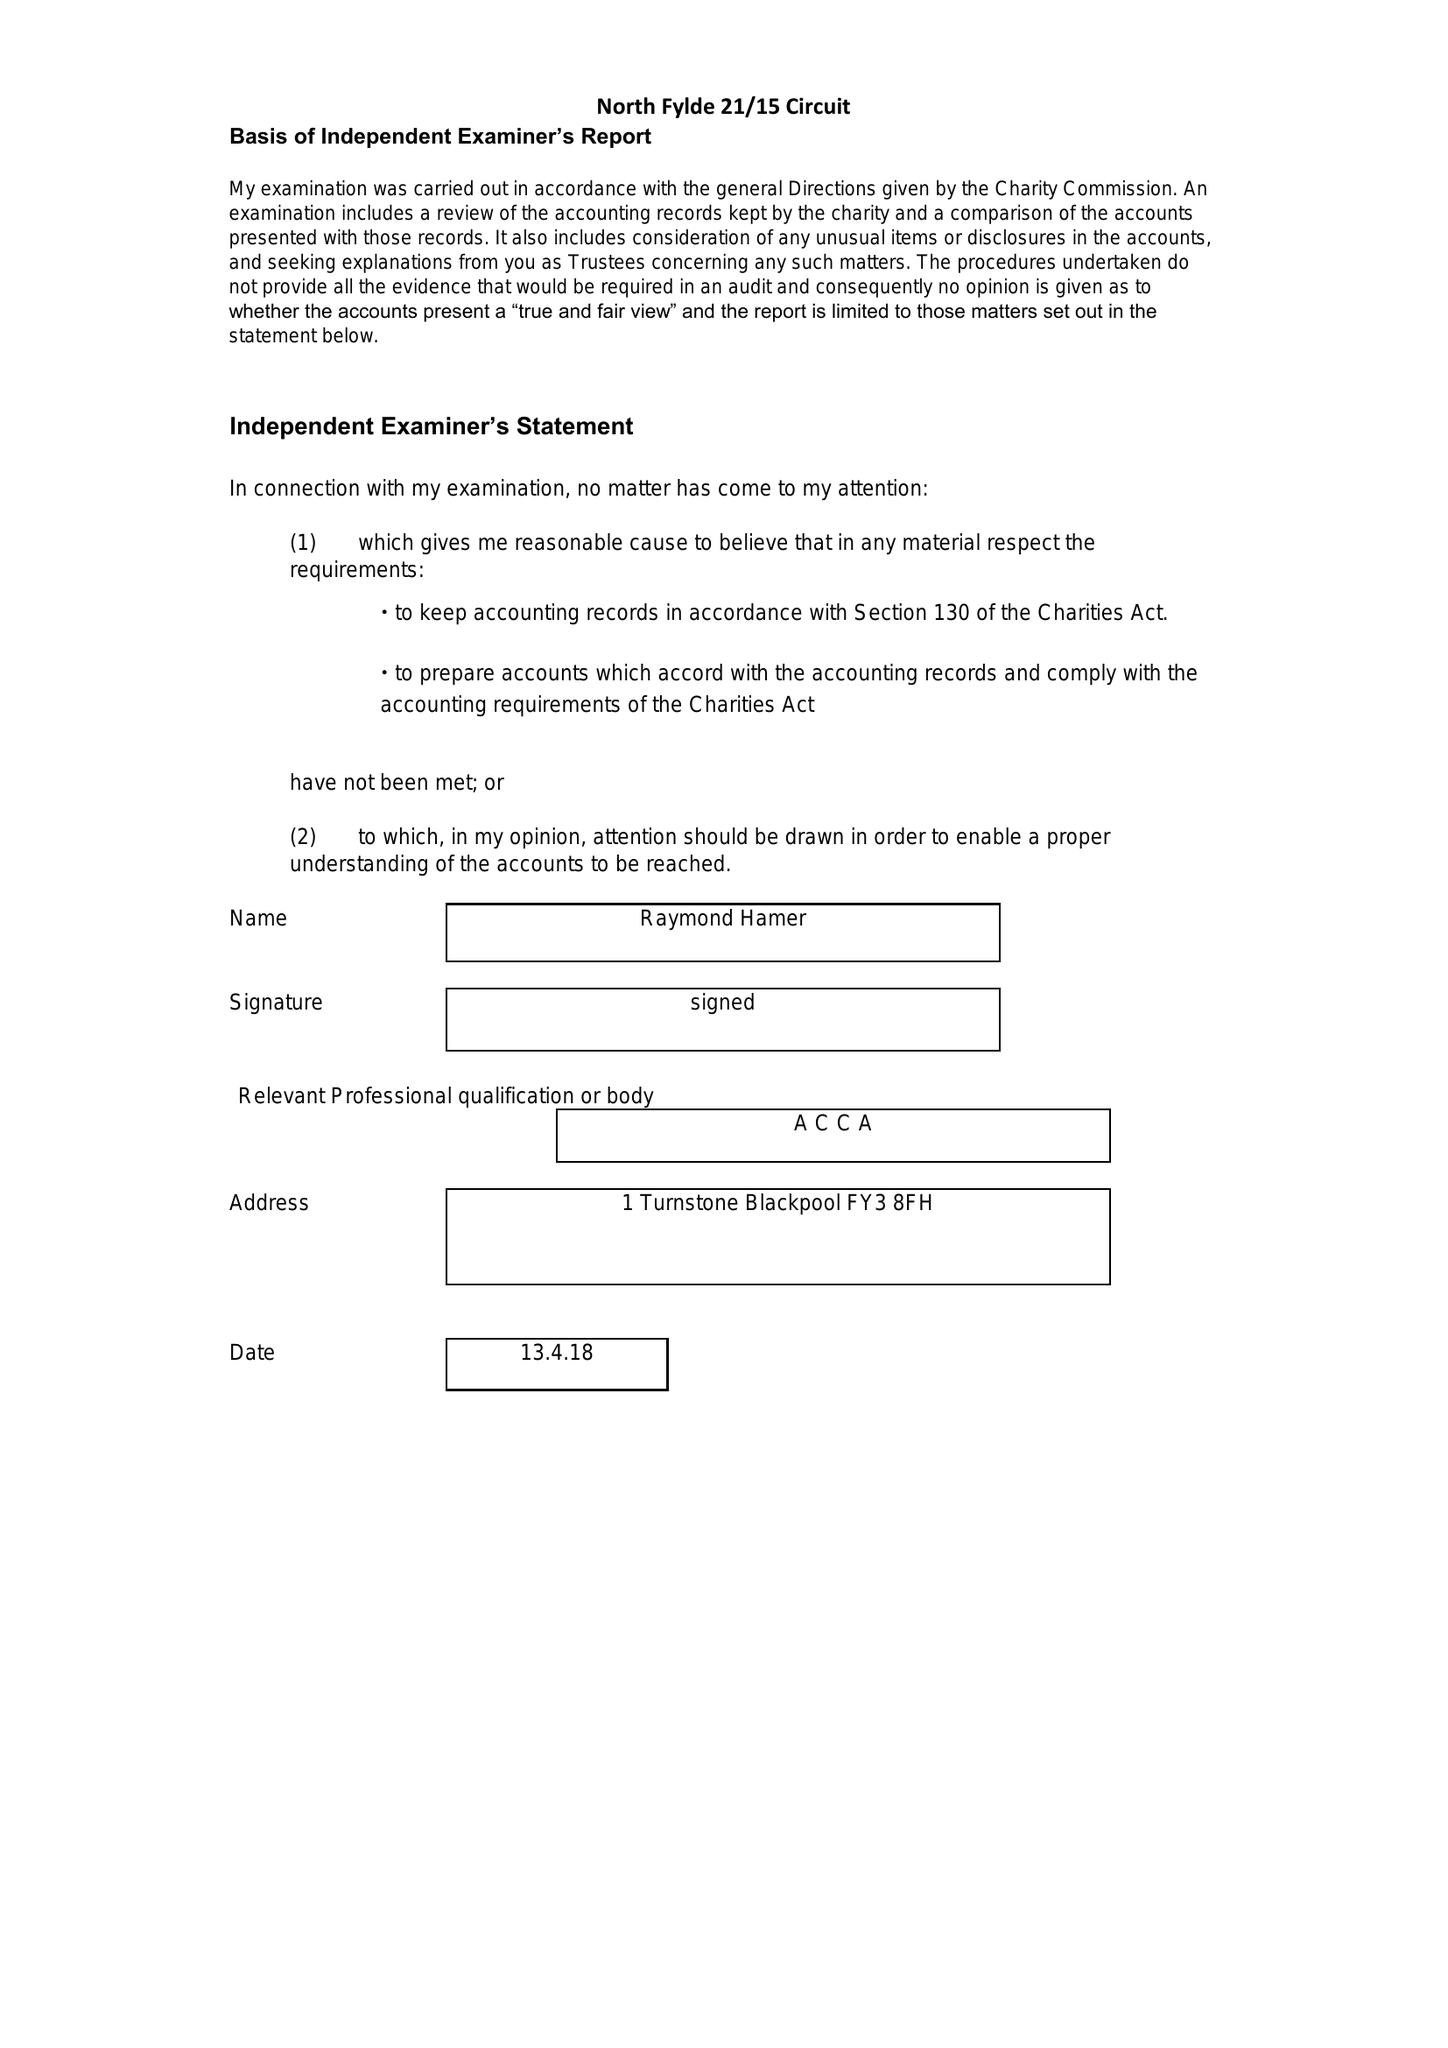What is the value for the charity_name?
Answer the question using a single word or phrase. The Methodist Church, North Fylde Circuit 